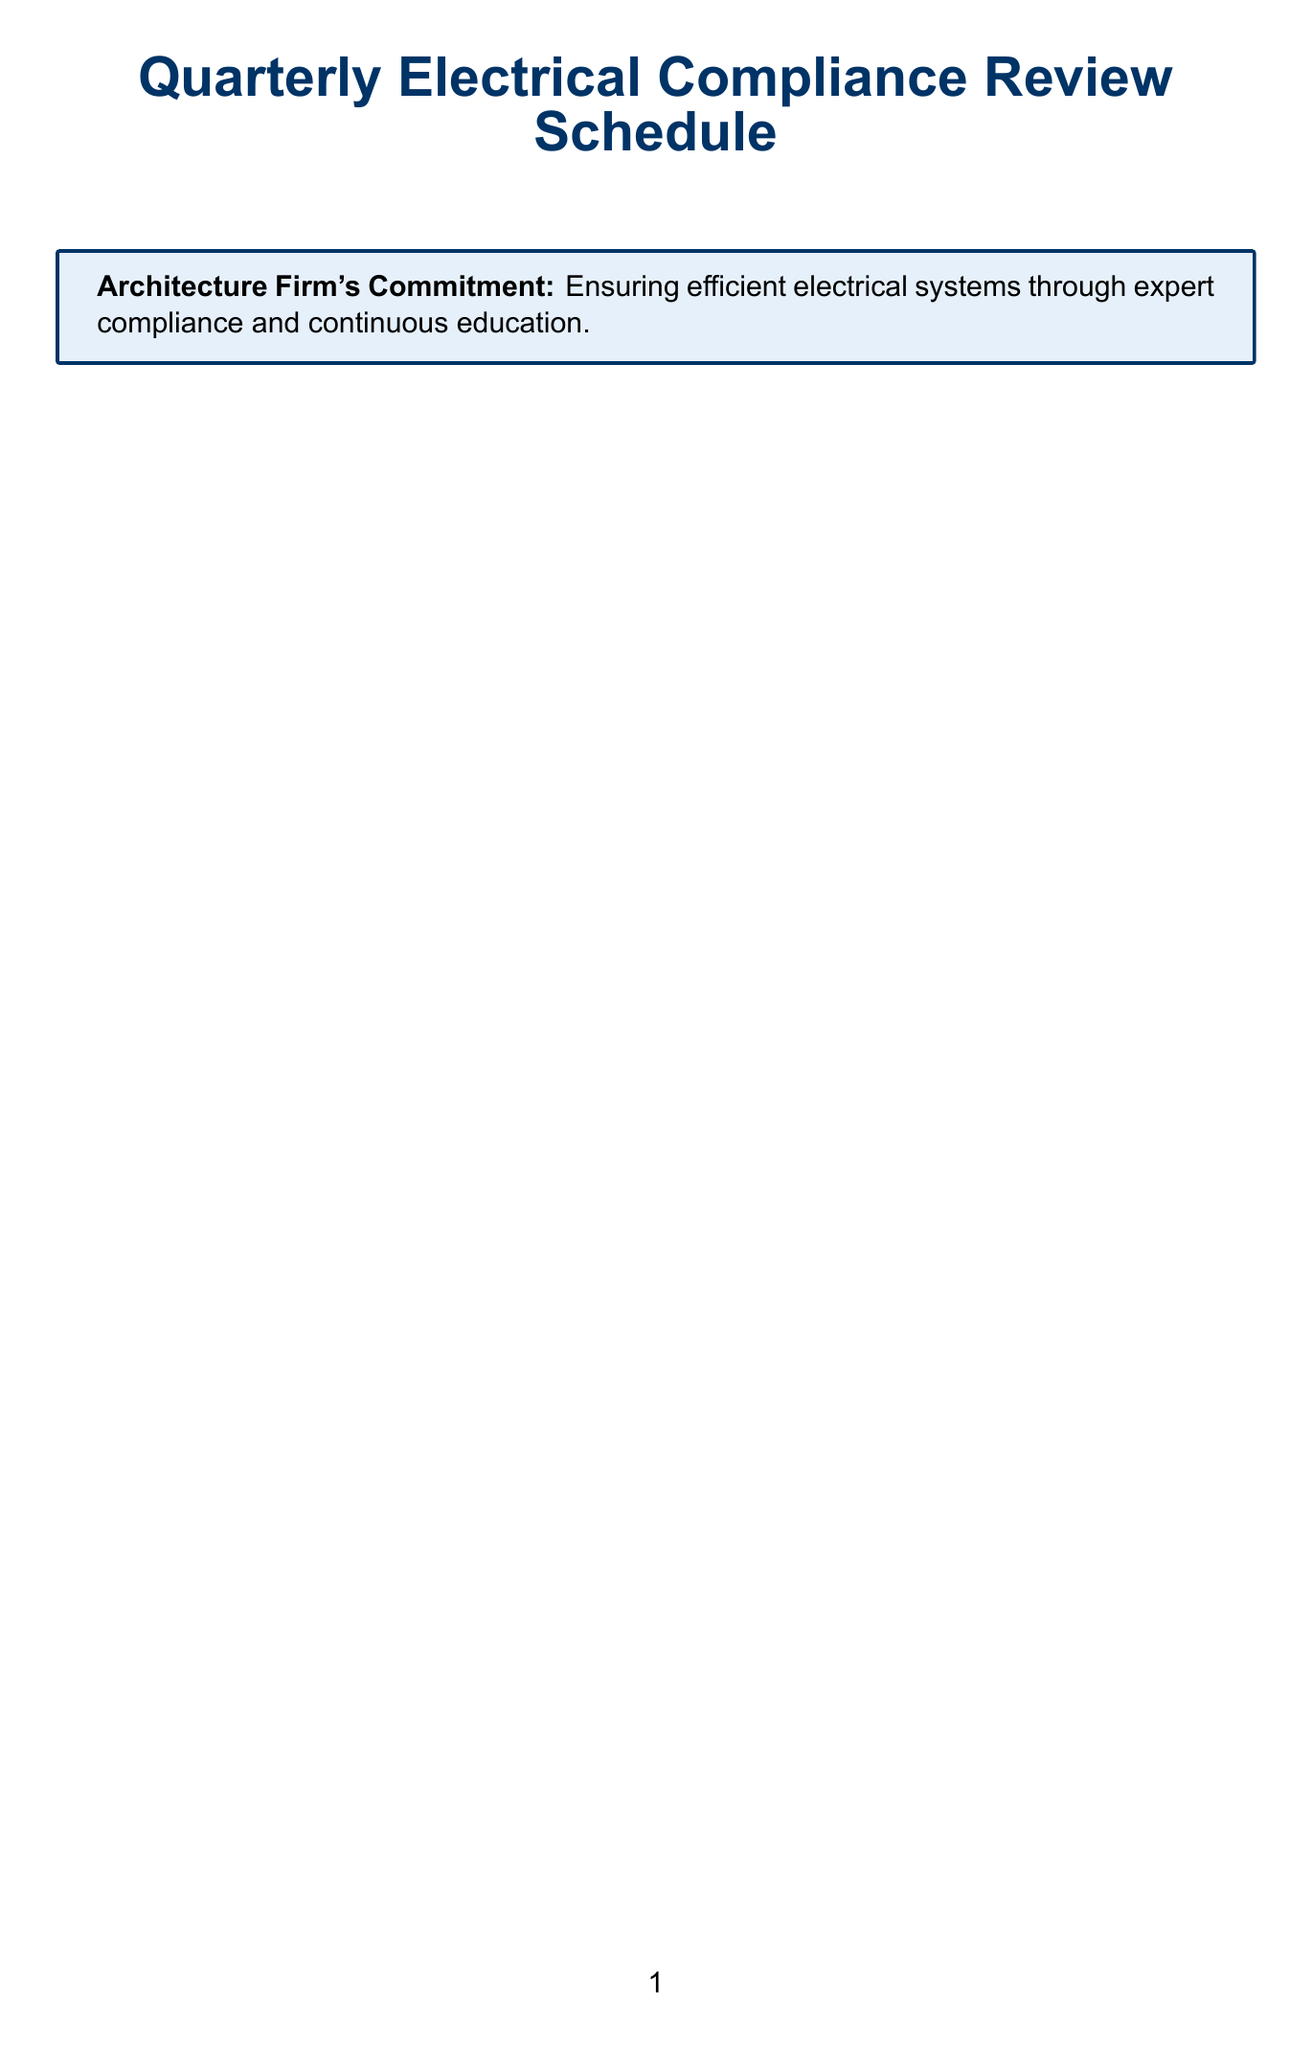what is the duration of the National Electrical Code Updates Review session? The duration of the National Electrical Code Updates Review session is specified in the document as 4 hours.
Answer: 4 hours who presents the ASHRAE 90.1 Energy Standard Compliance Workshop? The presenters for the ASHRAE 90.1 Energy Standard Compliance Workshop are listed as Senior Mechanical Engineer and LEED Accredited Professional.
Answer: Senior Mechanical Engineer, LEED Accredited Professional how often are the Quarterly review sessions held? The frequency of the Quarterly review sessions is indicated in the document as being held quarterly.
Answer: Quarterly what are the key topics of the Project-Specific Electrical Compliance Review? The document lists the key topics of the Project-Specific Electrical Compliance Review, including review of ongoing projects, identification of compliance challenges, and strategies for meeting project-specific requirements.
Answer: Review of ongoing projects, identification of compliance challenges, strategies for meeting project-specific requirements how long is the Local Building Energy Efficiency Codes Review session? The document states the duration of the Local Building Energy Efficiency Codes Review session as 2 hours.
Answer: 2 hours which role monitors changes in energy standards? The role responsible for monitoring changes in energy standards, as outlined in the document, is the Energy Efficiency Specialist.
Answer: Energy Efficiency Specialist which organization provides the Online NEC Code Navigator Subscription? The provider of the Online NEC Code Navigator Subscription is listed in the document as the National Fire Protection Association (NFPA).
Answer: National Fire Protection Association (NFPA) what is the purpose of the Compliance Team? The Compliance Team's purpose is described in the document as overseeing quarterly review sessions, liaison with regulatory bodies, and ensuring project compliance with electrical codes.
Answer: Oversee quarterly review sessions, liaison with regulatory bodies, ensure project compliance with electrical codes 